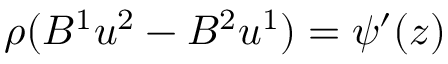Convert formula to latex. <formula><loc_0><loc_0><loc_500><loc_500>\rho ( B ^ { 1 } u ^ { 2 } - B ^ { 2 } u ^ { 1 } ) = \psi ^ { \prime } ( z )</formula> 